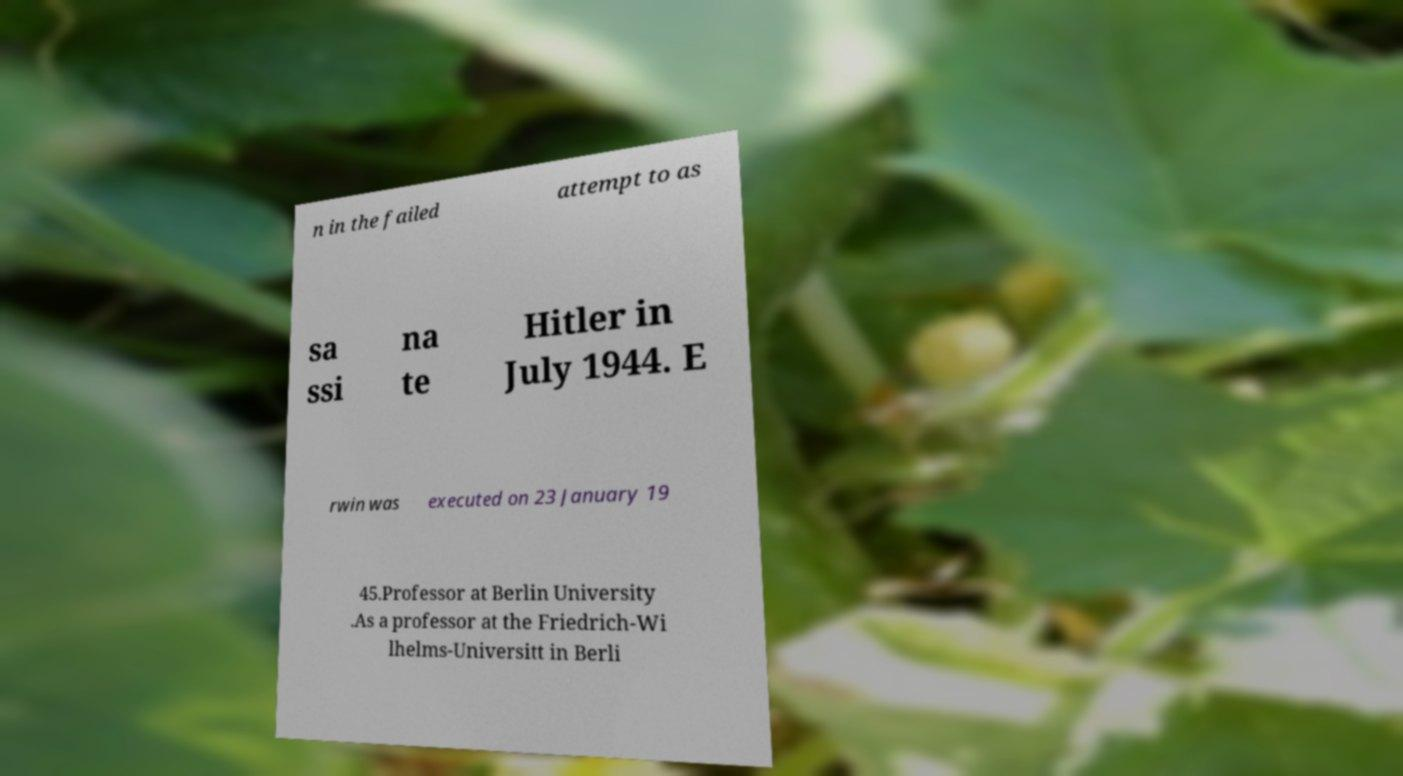Could you extract and type out the text from this image? n in the failed attempt to as sa ssi na te Hitler in July 1944. E rwin was executed on 23 January 19 45.Professor at Berlin University .As a professor at the Friedrich-Wi lhelms-Universitt in Berli 